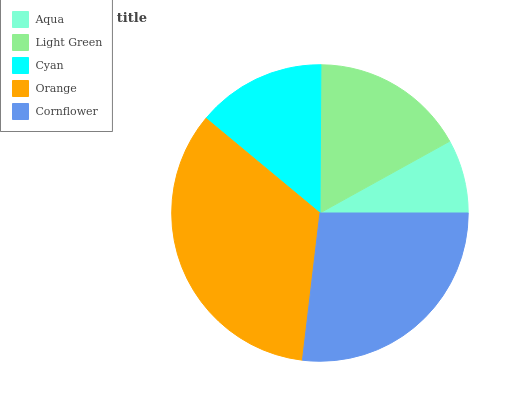Is Aqua the minimum?
Answer yes or no. Yes. Is Orange the maximum?
Answer yes or no. Yes. Is Light Green the minimum?
Answer yes or no. No. Is Light Green the maximum?
Answer yes or no. No. Is Light Green greater than Aqua?
Answer yes or no. Yes. Is Aqua less than Light Green?
Answer yes or no. Yes. Is Aqua greater than Light Green?
Answer yes or no. No. Is Light Green less than Aqua?
Answer yes or no. No. Is Light Green the high median?
Answer yes or no. Yes. Is Light Green the low median?
Answer yes or no. Yes. Is Cyan the high median?
Answer yes or no. No. Is Aqua the low median?
Answer yes or no. No. 